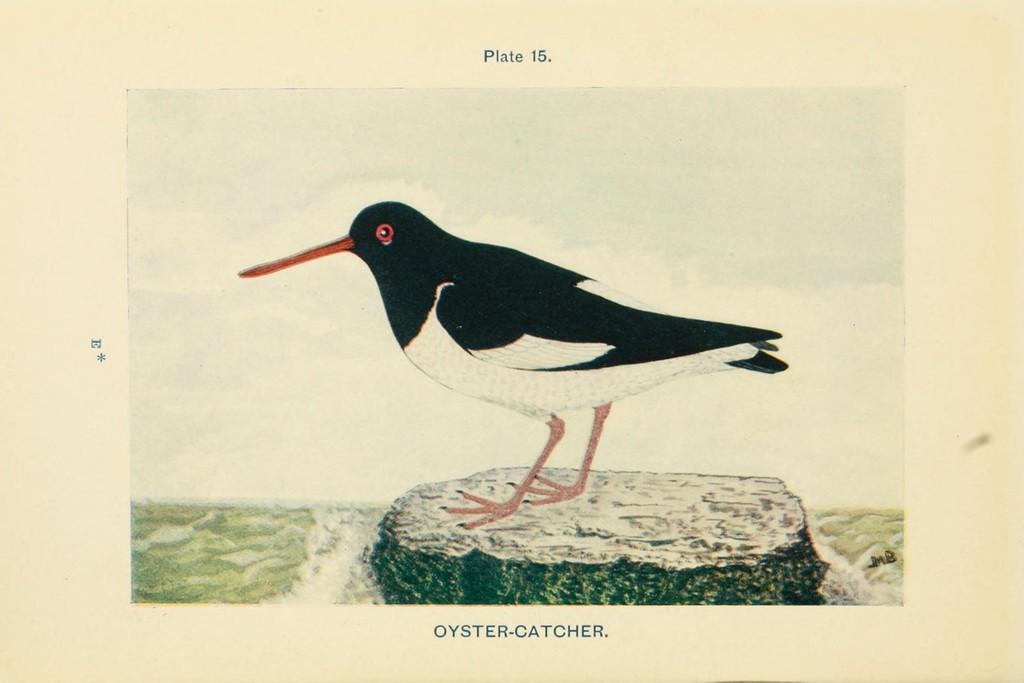Can you describe this image briefly? This is a painting in this picture in the center there is one bird, at the bottom there is grass. On the top of the image there is some text written and at the bottom also there is some text written. 